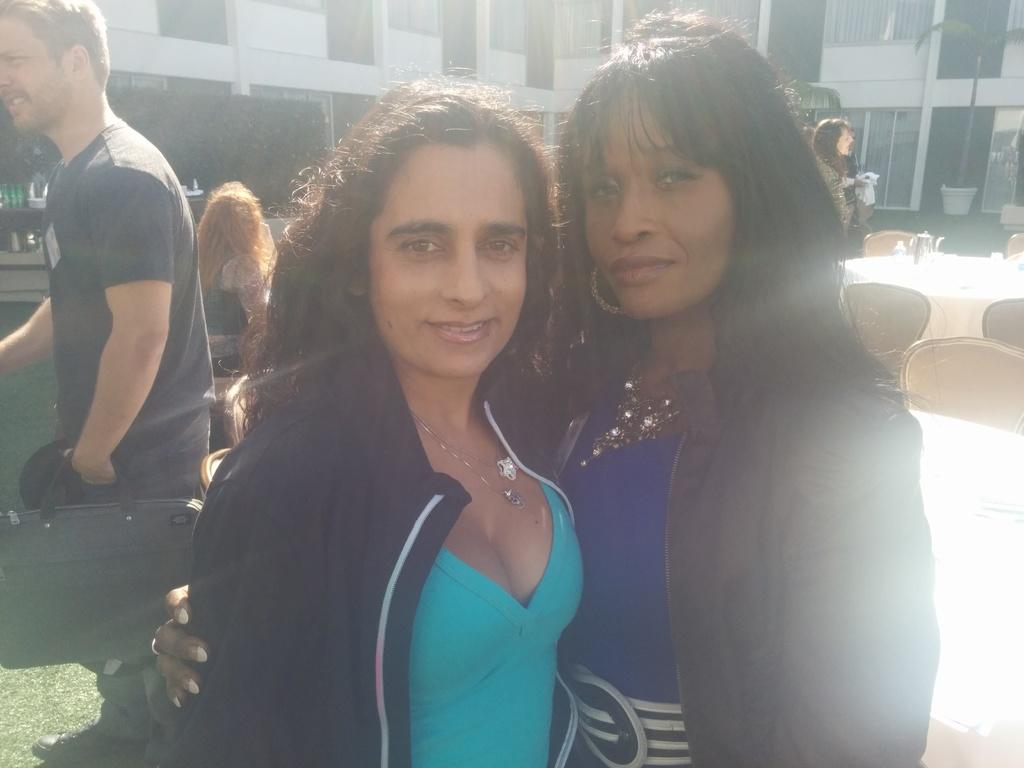What can be seen in the image involving people? There are people standing in the image. What type of furniture is present in the image? There are chairs and a table in the image. What is visible in the background of the image? Buildings are visible in the image. What is the man holding in his hand? The man is holding a bag in his hand. Where is the hydrant located in the image? There is no hydrant present in the image. What type of rock is being used as a table in the image? There is no rock being used as a table in the image; it is a regular table. 